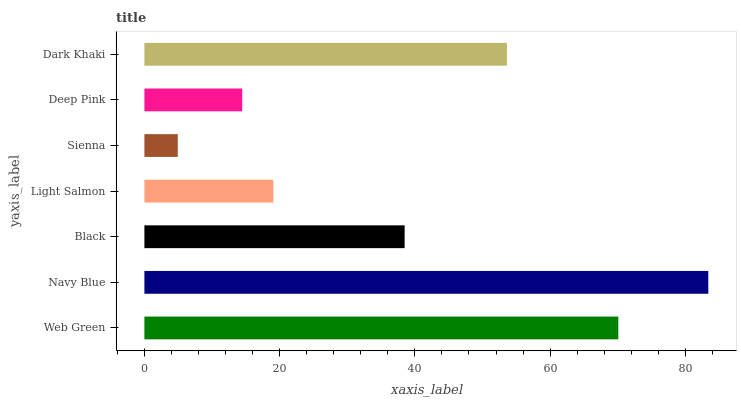Is Sienna the minimum?
Answer yes or no. Yes. Is Navy Blue the maximum?
Answer yes or no. Yes. Is Black the minimum?
Answer yes or no. No. Is Black the maximum?
Answer yes or no. No. Is Navy Blue greater than Black?
Answer yes or no. Yes. Is Black less than Navy Blue?
Answer yes or no. Yes. Is Black greater than Navy Blue?
Answer yes or no. No. Is Navy Blue less than Black?
Answer yes or no. No. Is Black the high median?
Answer yes or no. Yes. Is Black the low median?
Answer yes or no. Yes. Is Deep Pink the high median?
Answer yes or no. No. Is Deep Pink the low median?
Answer yes or no. No. 